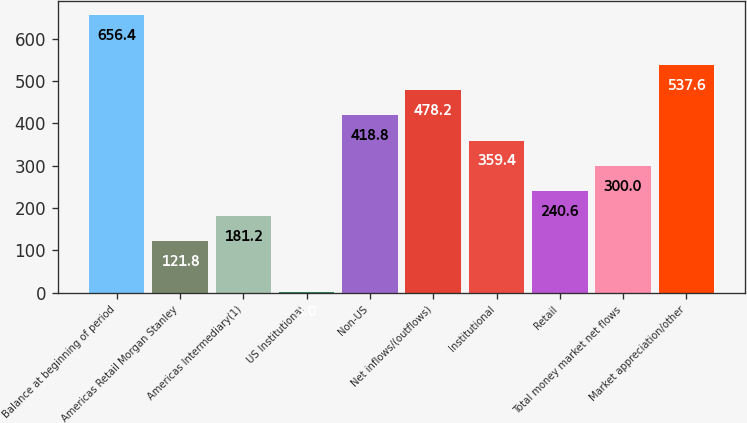Convert chart. <chart><loc_0><loc_0><loc_500><loc_500><bar_chart><fcel>Balance at beginning of period<fcel>Americas Retail Morgan Stanley<fcel>Americas Intermediary(1)<fcel>US Institutional<fcel>Non-US<fcel>Net inflows/(outflows)<fcel>Institutional<fcel>Retail<fcel>Total money market net flows<fcel>Market appreciation/other<nl><fcel>656.4<fcel>121.8<fcel>181.2<fcel>3<fcel>418.8<fcel>478.2<fcel>359.4<fcel>240.6<fcel>300<fcel>537.6<nl></chart> 